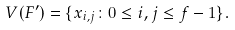Convert formula to latex. <formula><loc_0><loc_0><loc_500><loc_500>V ( F ^ { \prime } ) = \{ x _ { i , j } \colon 0 \leq i , j \leq f - 1 \} .</formula> 